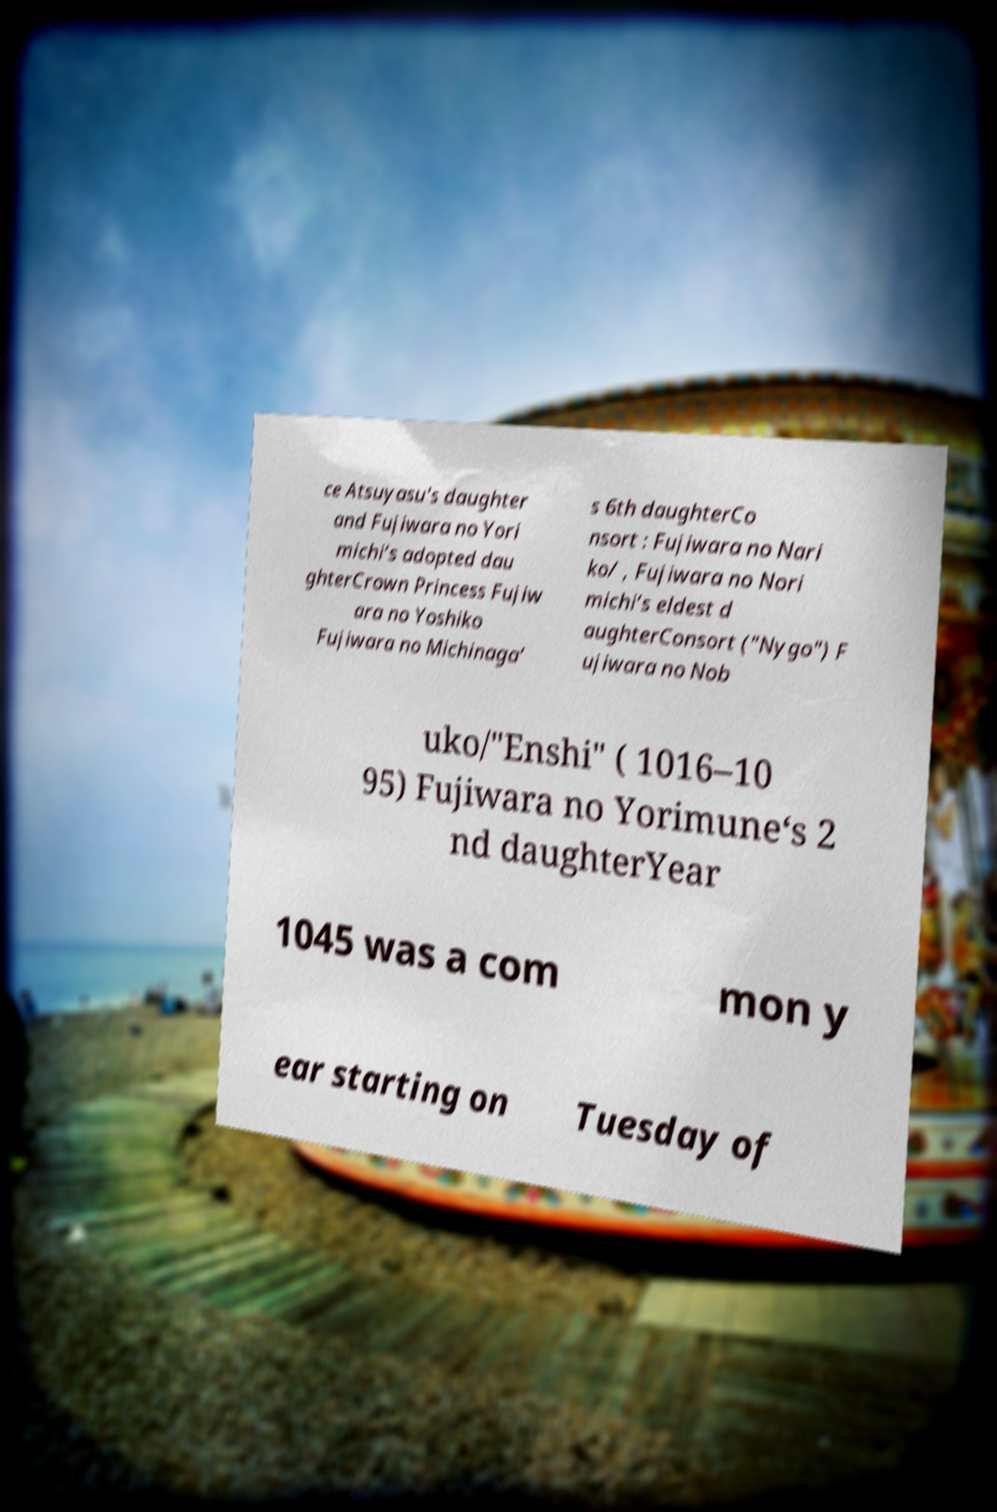Can you accurately transcribe the text from the provided image for me? ce Atsuyasu's daughter and Fujiwara no Yori michi‘s adopted dau ghterCrown Princess Fujiw ara no Yoshiko Fujiwara no Michinaga‘ s 6th daughterCo nsort : Fujiwara no Nari ko/ , Fujiwara no Nori michi‘s eldest d aughterConsort ("Nygo") F ujiwara no Nob uko/"Enshi" ( 1016–10 95) Fujiwara no Yorimune‘s 2 nd daughterYear 1045 was a com mon y ear starting on Tuesday of 